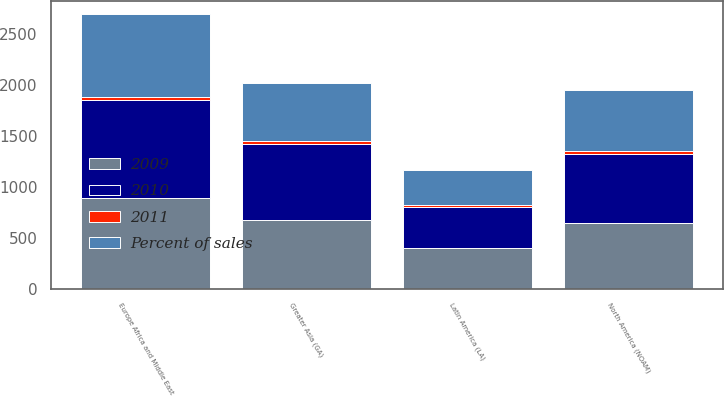<chart> <loc_0><loc_0><loc_500><loc_500><stacked_bar_chart><ecel><fcel>Europe Africa and Middle East<fcel>Greater Asia (GA)<fcel>North America (NOAM)<fcel>Latin America (LA)<nl><fcel>2010<fcel>957<fcel>745<fcel>678<fcel>408<nl><fcel>2011<fcel>34<fcel>27<fcel>24<fcel>15<nl><fcel>2009<fcel>897<fcel>677<fcel>651<fcel>398<nl><fcel>Percent of sales<fcel>808<fcel>575<fcel>600<fcel>343<nl></chart> 